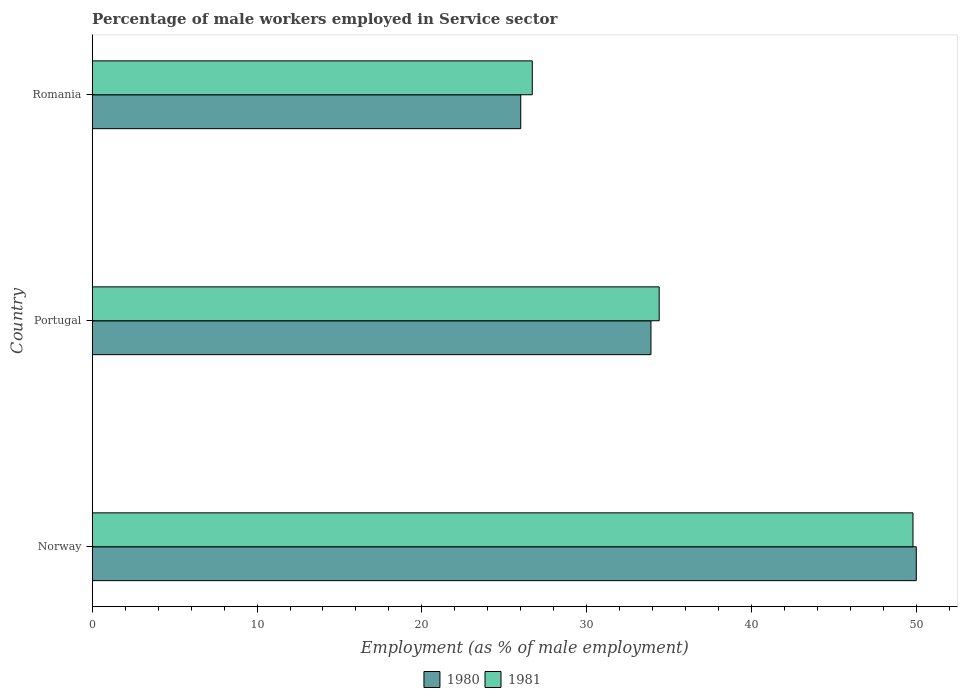How many different coloured bars are there?
Your answer should be very brief. 2. How many groups of bars are there?
Keep it short and to the point. 3. Are the number of bars on each tick of the Y-axis equal?
Provide a succinct answer. Yes. How many bars are there on the 3rd tick from the bottom?
Give a very brief answer. 2. What is the label of the 1st group of bars from the top?
Ensure brevity in your answer.  Romania. In how many cases, is the number of bars for a given country not equal to the number of legend labels?
Ensure brevity in your answer.  0. Across all countries, what is the minimum percentage of male workers employed in Service sector in 1981?
Offer a very short reply. 26.7. In which country was the percentage of male workers employed in Service sector in 1980 maximum?
Offer a terse response. Norway. In which country was the percentage of male workers employed in Service sector in 1981 minimum?
Offer a terse response. Romania. What is the total percentage of male workers employed in Service sector in 1981 in the graph?
Provide a succinct answer. 110.9. What is the difference between the percentage of male workers employed in Service sector in 1980 in Romania and the percentage of male workers employed in Service sector in 1981 in Norway?
Provide a succinct answer. -23.8. What is the average percentage of male workers employed in Service sector in 1981 per country?
Make the answer very short. 36.97. What is the difference between the percentage of male workers employed in Service sector in 1980 and percentage of male workers employed in Service sector in 1981 in Norway?
Give a very brief answer. 0.2. What is the ratio of the percentage of male workers employed in Service sector in 1981 in Norway to that in Portugal?
Offer a very short reply. 1.45. What is the difference between the highest and the second highest percentage of male workers employed in Service sector in 1981?
Your answer should be compact. 15.4. What is the difference between the highest and the lowest percentage of male workers employed in Service sector in 1981?
Offer a very short reply. 23.1. Is the sum of the percentage of male workers employed in Service sector in 1981 in Norway and Portugal greater than the maximum percentage of male workers employed in Service sector in 1980 across all countries?
Offer a terse response. Yes. Are all the bars in the graph horizontal?
Your response must be concise. Yes. Are the values on the major ticks of X-axis written in scientific E-notation?
Make the answer very short. No. Does the graph contain grids?
Your answer should be very brief. No. How many legend labels are there?
Offer a very short reply. 2. How are the legend labels stacked?
Keep it short and to the point. Horizontal. What is the title of the graph?
Your response must be concise. Percentage of male workers employed in Service sector. Does "1995" appear as one of the legend labels in the graph?
Offer a very short reply. No. What is the label or title of the X-axis?
Your answer should be compact. Employment (as % of male employment). What is the label or title of the Y-axis?
Your answer should be compact. Country. What is the Employment (as % of male employment) of 1981 in Norway?
Ensure brevity in your answer.  49.8. What is the Employment (as % of male employment) in 1980 in Portugal?
Provide a short and direct response. 33.9. What is the Employment (as % of male employment) in 1981 in Portugal?
Offer a very short reply. 34.4. What is the Employment (as % of male employment) in 1981 in Romania?
Offer a terse response. 26.7. Across all countries, what is the maximum Employment (as % of male employment) of 1981?
Your answer should be very brief. 49.8. Across all countries, what is the minimum Employment (as % of male employment) in 1980?
Your answer should be compact. 26. Across all countries, what is the minimum Employment (as % of male employment) of 1981?
Give a very brief answer. 26.7. What is the total Employment (as % of male employment) in 1980 in the graph?
Your response must be concise. 109.9. What is the total Employment (as % of male employment) of 1981 in the graph?
Your answer should be very brief. 110.9. What is the difference between the Employment (as % of male employment) in 1980 in Norway and that in Portugal?
Provide a short and direct response. 16.1. What is the difference between the Employment (as % of male employment) in 1981 in Norway and that in Romania?
Keep it short and to the point. 23.1. What is the difference between the Employment (as % of male employment) of 1981 in Portugal and that in Romania?
Offer a terse response. 7.7. What is the difference between the Employment (as % of male employment) in 1980 in Norway and the Employment (as % of male employment) in 1981 in Portugal?
Provide a succinct answer. 15.6. What is the difference between the Employment (as % of male employment) in 1980 in Norway and the Employment (as % of male employment) in 1981 in Romania?
Your answer should be compact. 23.3. What is the difference between the Employment (as % of male employment) of 1980 in Portugal and the Employment (as % of male employment) of 1981 in Romania?
Your answer should be compact. 7.2. What is the average Employment (as % of male employment) of 1980 per country?
Provide a succinct answer. 36.63. What is the average Employment (as % of male employment) of 1981 per country?
Your answer should be very brief. 36.97. What is the difference between the Employment (as % of male employment) in 1980 and Employment (as % of male employment) in 1981 in Romania?
Offer a terse response. -0.7. What is the ratio of the Employment (as % of male employment) of 1980 in Norway to that in Portugal?
Make the answer very short. 1.47. What is the ratio of the Employment (as % of male employment) in 1981 in Norway to that in Portugal?
Offer a very short reply. 1.45. What is the ratio of the Employment (as % of male employment) of 1980 in Norway to that in Romania?
Your answer should be very brief. 1.92. What is the ratio of the Employment (as % of male employment) of 1981 in Norway to that in Romania?
Ensure brevity in your answer.  1.87. What is the ratio of the Employment (as % of male employment) in 1980 in Portugal to that in Romania?
Your response must be concise. 1.3. What is the ratio of the Employment (as % of male employment) of 1981 in Portugal to that in Romania?
Your response must be concise. 1.29. What is the difference between the highest and the second highest Employment (as % of male employment) of 1980?
Your response must be concise. 16.1. What is the difference between the highest and the lowest Employment (as % of male employment) of 1980?
Provide a short and direct response. 24. What is the difference between the highest and the lowest Employment (as % of male employment) in 1981?
Ensure brevity in your answer.  23.1. 